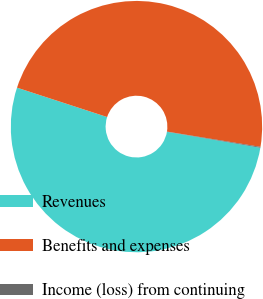Convert chart. <chart><loc_0><loc_0><loc_500><loc_500><pie_chart><fcel>Revenues<fcel>Benefits and expenses<fcel>Income (loss) from continuing<nl><fcel>52.32%<fcel>47.57%<fcel>0.11%<nl></chart> 